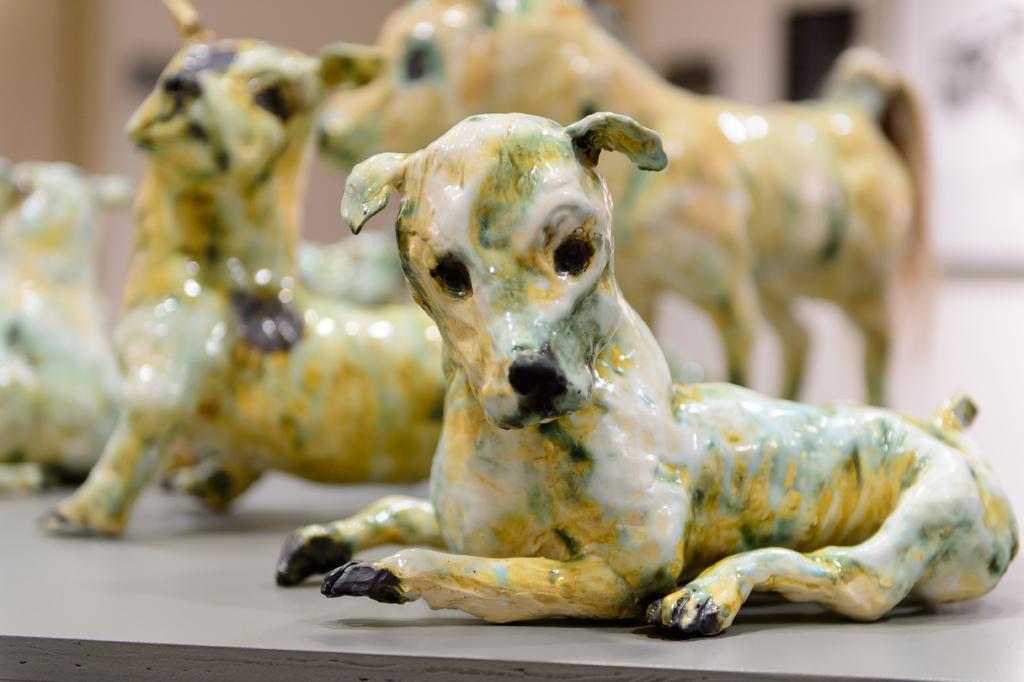In one or two sentences, can you explain what this image depicts? In this picture there are ceramic animals. At the bottom it looks like a table. At the back image is blurry. 